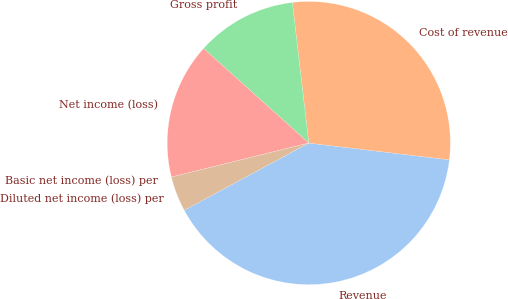<chart> <loc_0><loc_0><loc_500><loc_500><pie_chart><fcel>Revenue<fcel>Cost of revenue<fcel>Gross profit<fcel>Net income (loss)<fcel>Basic net income (loss) per<fcel>Diluted net income (loss) per<nl><fcel>40.23%<fcel>28.74%<fcel>11.49%<fcel>15.51%<fcel>0.0%<fcel>4.02%<nl></chart> 